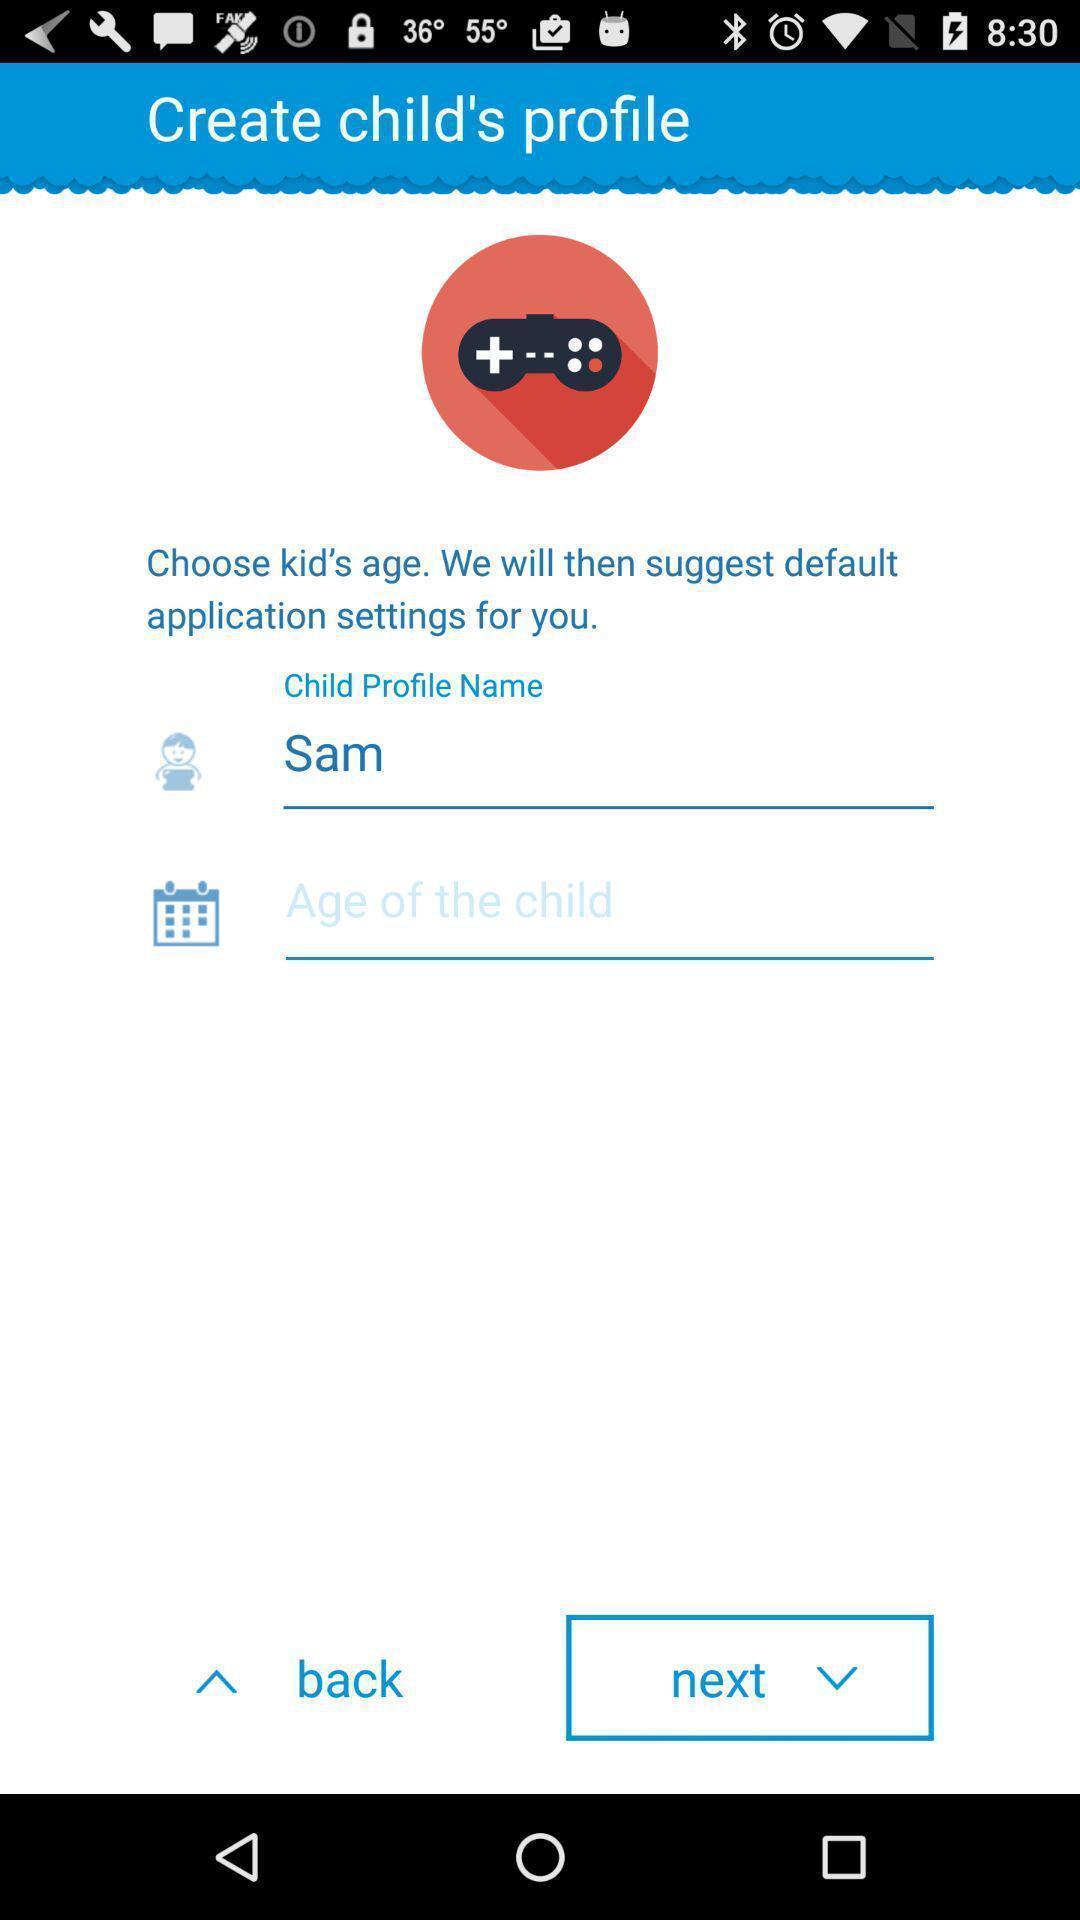What is the overall content of this screenshot? Page to create the child 's profile. 